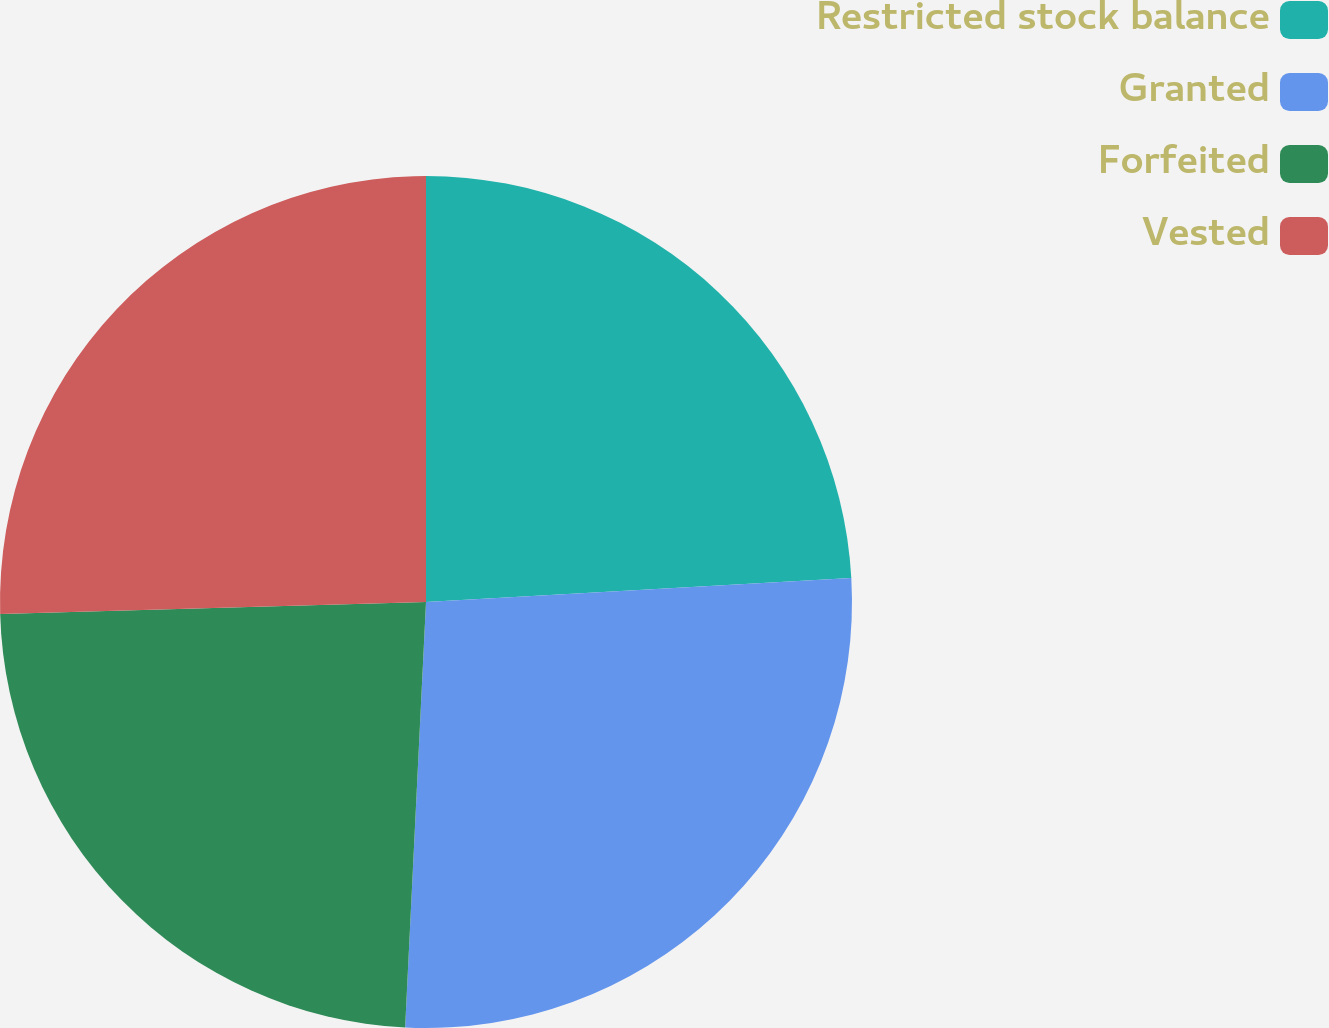<chart> <loc_0><loc_0><loc_500><loc_500><pie_chart><fcel>Restricted stock balance<fcel>Granted<fcel>Forfeited<fcel>Vested<nl><fcel>24.1%<fcel>26.68%<fcel>23.77%<fcel>25.45%<nl></chart> 